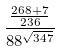<formula> <loc_0><loc_0><loc_500><loc_500>\frac { \frac { 2 6 8 + 7 } { 2 3 6 } } { 8 8 ^ { \sqrt { 3 4 7 } } }</formula> 